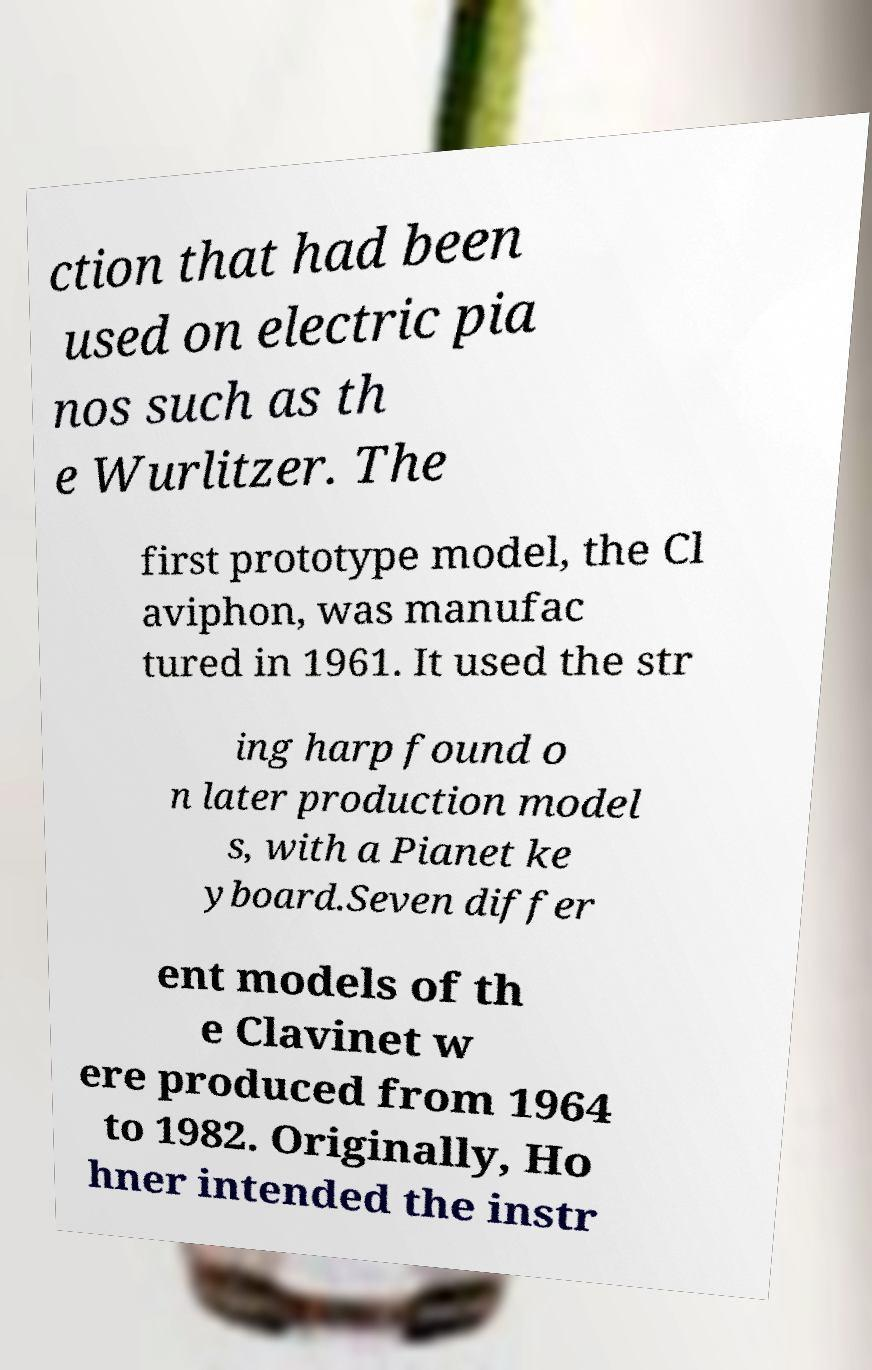For documentation purposes, I need the text within this image transcribed. Could you provide that? ction that had been used on electric pia nos such as th e Wurlitzer. The first prototype model, the Cl aviphon, was manufac tured in 1961. It used the str ing harp found o n later production model s, with a Pianet ke yboard.Seven differ ent models of th e Clavinet w ere produced from 1964 to 1982. Originally, Ho hner intended the instr 